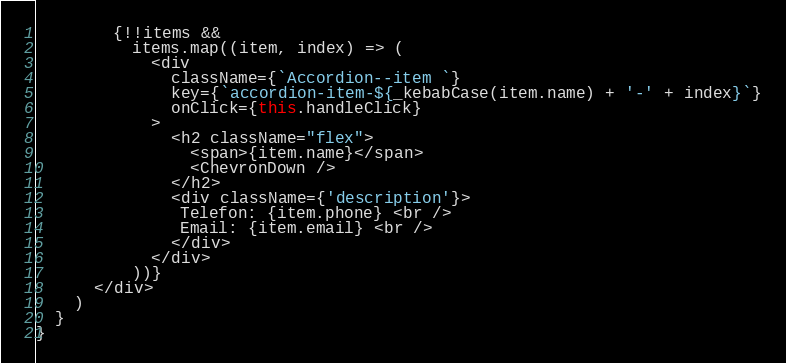<code> <loc_0><loc_0><loc_500><loc_500><_JavaScript_>        {!!items &&
          items.map((item, index) => (
            <div
              className={`Accordion--item `}
              key={`accordion-item-${_kebabCase(item.name) + '-' + index}`}
              onClick={this.handleClick}
            >
              <h2 className="flex">
                <span>{item.name}</span>
                <ChevronDown />
              </h2>
              <div className={'description'}>
               Telefon: {item.phone} <br />
               Email: {item.email} <br />
              </div>
            </div>
          ))}
      </div>
    )
  }
}
</code> 